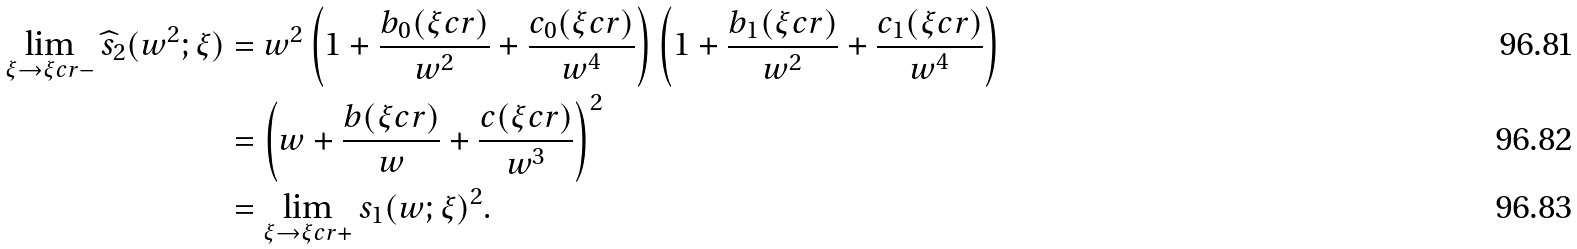<formula> <loc_0><loc_0><loc_500><loc_500>\lim _ { \xi \to \xi c r - } \widehat { s } _ { 2 } ( w ^ { 2 } ; \xi ) & = w ^ { 2 } \left ( 1 + \frac { b _ { 0 } ( \xi c r ) } { w ^ { 2 } } + \frac { c _ { 0 } ( \xi c r ) } { w ^ { 4 } } \right ) \left ( 1 + \frac { b _ { 1 } ( \xi c r ) } { w ^ { 2 } } + \frac { c _ { 1 } ( \xi c r ) } { w ^ { 4 } } \right ) \\ & = \left ( w + \frac { b ( \xi c r ) } { w } + \frac { c ( \xi c r ) } { w ^ { 3 } } \right ) ^ { 2 } \\ & = \lim _ { \xi \to \xi c r + } s _ { 1 } ( w ; \xi ) ^ { 2 } .</formula> 